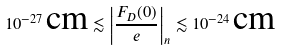Convert formula to latex. <formula><loc_0><loc_0><loc_500><loc_500>1 0 ^ { - 2 7 } \, \text {cm} \lesssim \left | \frac { F _ { D } ( 0 ) } { e } \right | _ { n } \lesssim 1 0 ^ { - 2 4 } \, \text {cm}</formula> 